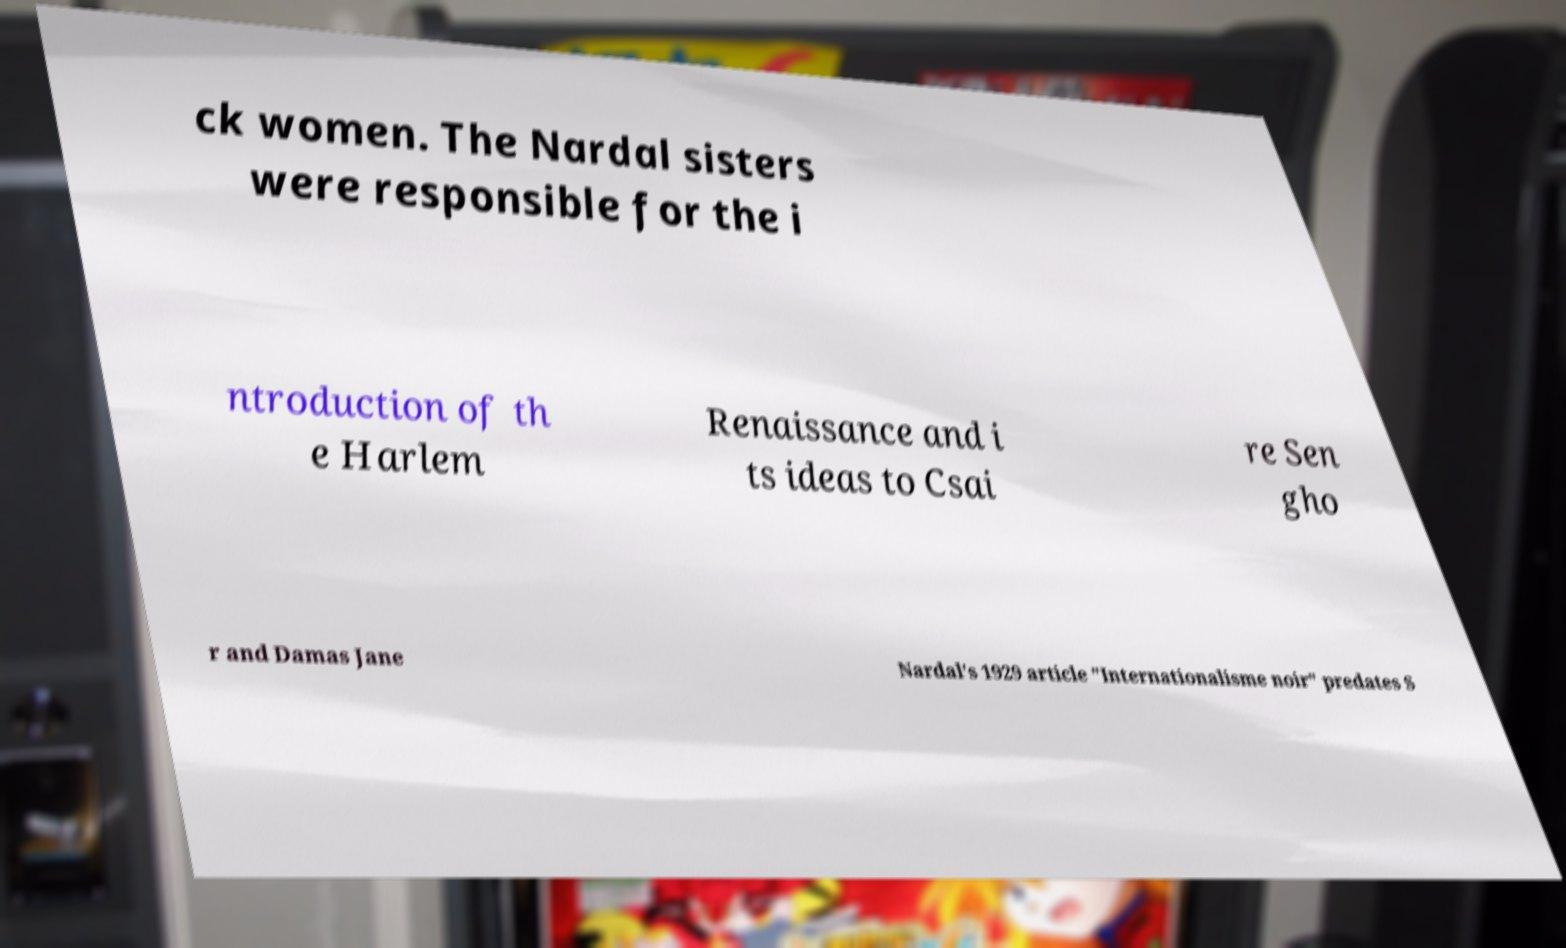Please read and relay the text visible in this image. What does it say? ck women. The Nardal sisters were responsible for the i ntroduction of th e Harlem Renaissance and i ts ideas to Csai re Sen gho r and Damas Jane Nardal's 1929 article "Internationalisme noir" predates S 